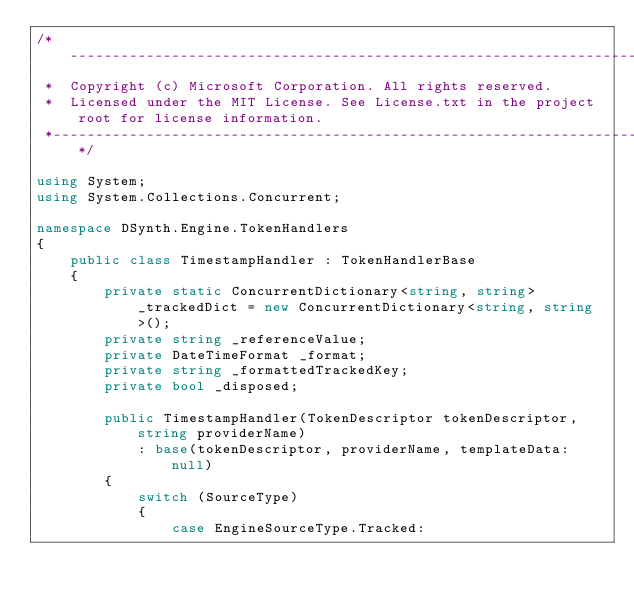Convert code to text. <code><loc_0><loc_0><loc_500><loc_500><_C#_>/*---------------------------------------------------------------------------------------------
 *  Copyright (c) Microsoft Corporation. All rights reserved.
 *  Licensed under the MIT License. See License.txt in the project root for license information.
 *--------------------------------------------------------------------------------------------*/

using System;
using System.Collections.Concurrent;

namespace DSynth.Engine.TokenHandlers
{
    public class TimestampHandler : TokenHandlerBase
    {
        private static ConcurrentDictionary<string, string> _trackedDict = new ConcurrentDictionary<string, string>();
        private string _referenceValue;
        private DateTimeFormat _format;
        private string _formattedTrackedKey;
        private bool _disposed;

        public TimestampHandler(TokenDescriptor tokenDescriptor, string providerName)
            : base(tokenDescriptor, providerName, templateData: null)
        {
            switch (SourceType)
            {
                case EngineSourceType.Tracked:</code> 